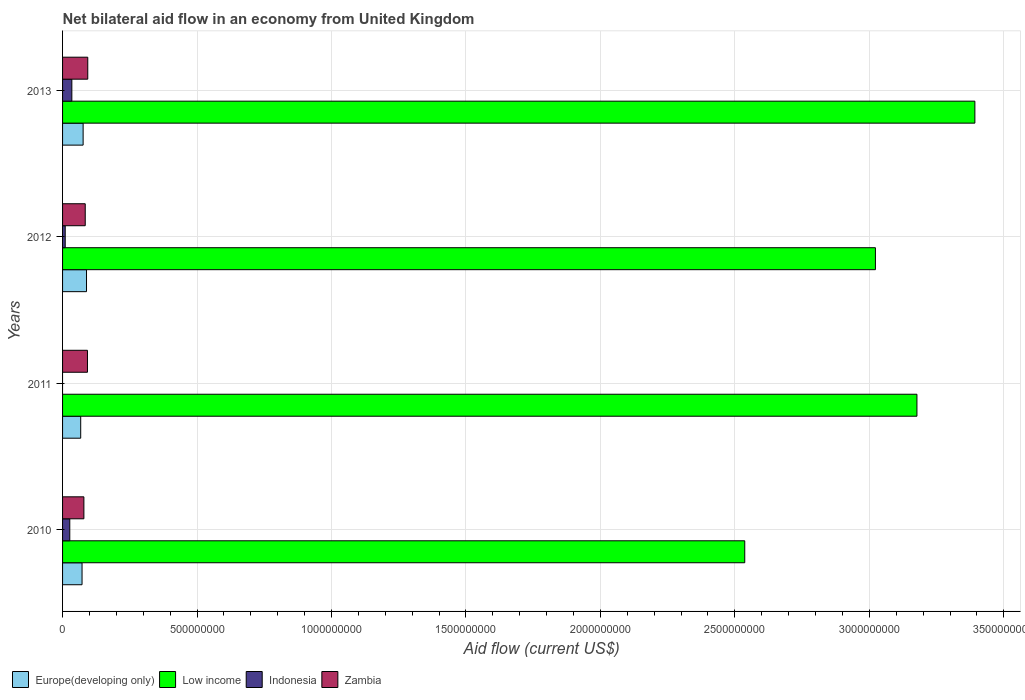How many different coloured bars are there?
Your response must be concise. 4. Are the number of bars on each tick of the Y-axis equal?
Your response must be concise. No. What is the label of the 1st group of bars from the top?
Give a very brief answer. 2013. In how many cases, is the number of bars for a given year not equal to the number of legend labels?
Offer a terse response. 1. What is the net bilateral aid flow in Europe(developing only) in 2011?
Your answer should be very brief. 6.74e+07. Across all years, what is the maximum net bilateral aid flow in Low income?
Offer a terse response. 3.39e+09. Across all years, what is the minimum net bilateral aid flow in Indonesia?
Keep it short and to the point. 0. In which year was the net bilateral aid flow in Europe(developing only) maximum?
Your answer should be compact. 2012. What is the total net bilateral aid flow in Europe(developing only) in the graph?
Give a very brief answer. 3.05e+08. What is the difference between the net bilateral aid flow in Zambia in 2010 and that in 2013?
Provide a succinct answer. -1.44e+07. What is the difference between the net bilateral aid flow in Low income in 2010 and the net bilateral aid flow in Indonesia in 2012?
Your response must be concise. 2.53e+09. What is the average net bilateral aid flow in Europe(developing only) per year?
Offer a very short reply. 7.63e+07. In the year 2013, what is the difference between the net bilateral aid flow in Indonesia and net bilateral aid flow in Europe(developing only)?
Your answer should be very brief. -4.19e+07. What is the ratio of the net bilateral aid flow in Zambia in 2011 to that in 2012?
Your response must be concise. 1.1. Is the difference between the net bilateral aid flow in Indonesia in 2010 and 2012 greater than the difference between the net bilateral aid flow in Europe(developing only) in 2010 and 2012?
Ensure brevity in your answer.  Yes. What is the difference between the highest and the second highest net bilateral aid flow in Low income?
Provide a short and direct response. 2.15e+08. What is the difference between the highest and the lowest net bilateral aid flow in Zambia?
Your answer should be very brief. 1.44e+07. In how many years, is the net bilateral aid flow in Europe(developing only) greater than the average net bilateral aid flow in Europe(developing only) taken over all years?
Provide a short and direct response. 2. Is it the case that in every year, the sum of the net bilateral aid flow in Indonesia and net bilateral aid flow in Zambia is greater than the sum of net bilateral aid flow in Europe(developing only) and net bilateral aid flow in Low income?
Your response must be concise. No. How many bars are there?
Offer a very short reply. 15. Does the graph contain any zero values?
Offer a terse response. Yes. Does the graph contain grids?
Your response must be concise. Yes. What is the title of the graph?
Provide a succinct answer. Net bilateral aid flow in an economy from United Kingdom. What is the label or title of the Y-axis?
Offer a very short reply. Years. What is the Aid flow (current US$) of Europe(developing only) in 2010?
Provide a succinct answer. 7.25e+07. What is the Aid flow (current US$) of Low income in 2010?
Give a very brief answer. 2.54e+09. What is the Aid flow (current US$) in Indonesia in 2010?
Provide a short and direct response. 2.68e+07. What is the Aid flow (current US$) of Zambia in 2010?
Your response must be concise. 7.93e+07. What is the Aid flow (current US$) in Europe(developing only) in 2011?
Provide a short and direct response. 6.74e+07. What is the Aid flow (current US$) in Low income in 2011?
Keep it short and to the point. 3.18e+09. What is the Aid flow (current US$) in Zambia in 2011?
Give a very brief answer. 9.26e+07. What is the Aid flow (current US$) in Europe(developing only) in 2012?
Give a very brief answer. 8.90e+07. What is the Aid flow (current US$) in Low income in 2012?
Your answer should be very brief. 3.02e+09. What is the Aid flow (current US$) of Indonesia in 2012?
Your answer should be very brief. 9.88e+06. What is the Aid flow (current US$) of Zambia in 2012?
Make the answer very short. 8.43e+07. What is the Aid flow (current US$) of Europe(developing only) in 2013?
Ensure brevity in your answer.  7.64e+07. What is the Aid flow (current US$) of Low income in 2013?
Your answer should be very brief. 3.39e+09. What is the Aid flow (current US$) in Indonesia in 2013?
Ensure brevity in your answer.  3.45e+07. What is the Aid flow (current US$) of Zambia in 2013?
Your answer should be very brief. 9.37e+07. Across all years, what is the maximum Aid flow (current US$) in Europe(developing only)?
Give a very brief answer. 8.90e+07. Across all years, what is the maximum Aid flow (current US$) of Low income?
Make the answer very short. 3.39e+09. Across all years, what is the maximum Aid flow (current US$) in Indonesia?
Keep it short and to the point. 3.45e+07. Across all years, what is the maximum Aid flow (current US$) in Zambia?
Provide a succinct answer. 9.37e+07. Across all years, what is the minimum Aid flow (current US$) of Europe(developing only)?
Your answer should be compact. 6.74e+07. Across all years, what is the minimum Aid flow (current US$) of Low income?
Offer a very short reply. 2.54e+09. Across all years, what is the minimum Aid flow (current US$) in Zambia?
Your answer should be very brief. 7.93e+07. What is the total Aid flow (current US$) of Europe(developing only) in the graph?
Ensure brevity in your answer.  3.05e+08. What is the total Aid flow (current US$) of Low income in the graph?
Keep it short and to the point. 1.21e+1. What is the total Aid flow (current US$) in Indonesia in the graph?
Give a very brief answer. 7.12e+07. What is the total Aid flow (current US$) of Zambia in the graph?
Make the answer very short. 3.50e+08. What is the difference between the Aid flow (current US$) of Europe(developing only) in 2010 and that in 2011?
Your response must be concise. 5.03e+06. What is the difference between the Aid flow (current US$) in Low income in 2010 and that in 2011?
Provide a short and direct response. -6.40e+08. What is the difference between the Aid flow (current US$) in Zambia in 2010 and that in 2011?
Give a very brief answer. -1.33e+07. What is the difference between the Aid flow (current US$) of Europe(developing only) in 2010 and that in 2012?
Keep it short and to the point. -1.66e+07. What is the difference between the Aid flow (current US$) in Low income in 2010 and that in 2012?
Provide a short and direct response. -4.86e+08. What is the difference between the Aid flow (current US$) in Indonesia in 2010 and that in 2012?
Your answer should be compact. 1.70e+07. What is the difference between the Aid flow (current US$) in Zambia in 2010 and that in 2012?
Ensure brevity in your answer.  -4.97e+06. What is the difference between the Aid flow (current US$) in Europe(developing only) in 2010 and that in 2013?
Offer a terse response. -3.98e+06. What is the difference between the Aid flow (current US$) of Low income in 2010 and that in 2013?
Your response must be concise. -8.56e+08. What is the difference between the Aid flow (current US$) in Indonesia in 2010 and that in 2013?
Offer a terse response. -7.66e+06. What is the difference between the Aid flow (current US$) of Zambia in 2010 and that in 2013?
Offer a very short reply. -1.44e+07. What is the difference between the Aid flow (current US$) of Europe(developing only) in 2011 and that in 2012?
Offer a terse response. -2.16e+07. What is the difference between the Aid flow (current US$) of Low income in 2011 and that in 2012?
Your answer should be compact. 1.54e+08. What is the difference between the Aid flow (current US$) in Zambia in 2011 and that in 2012?
Your answer should be compact. 8.32e+06. What is the difference between the Aid flow (current US$) in Europe(developing only) in 2011 and that in 2013?
Provide a succinct answer. -9.01e+06. What is the difference between the Aid flow (current US$) in Low income in 2011 and that in 2013?
Your response must be concise. -2.15e+08. What is the difference between the Aid flow (current US$) of Zambia in 2011 and that in 2013?
Ensure brevity in your answer.  -1.13e+06. What is the difference between the Aid flow (current US$) in Europe(developing only) in 2012 and that in 2013?
Provide a succinct answer. 1.26e+07. What is the difference between the Aid flow (current US$) in Low income in 2012 and that in 2013?
Make the answer very short. -3.70e+08. What is the difference between the Aid flow (current US$) of Indonesia in 2012 and that in 2013?
Give a very brief answer. -2.46e+07. What is the difference between the Aid flow (current US$) in Zambia in 2012 and that in 2013?
Ensure brevity in your answer.  -9.45e+06. What is the difference between the Aid flow (current US$) of Europe(developing only) in 2010 and the Aid flow (current US$) of Low income in 2011?
Offer a terse response. -3.10e+09. What is the difference between the Aid flow (current US$) in Europe(developing only) in 2010 and the Aid flow (current US$) in Zambia in 2011?
Keep it short and to the point. -2.01e+07. What is the difference between the Aid flow (current US$) in Low income in 2010 and the Aid flow (current US$) in Zambia in 2011?
Offer a very short reply. 2.44e+09. What is the difference between the Aid flow (current US$) of Indonesia in 2010 and the Aid flow (current US$) of Zambia in 2011?
Your answer should be very brief. -6.57e+07. What is the difference between the Aid flow (current US$) of Europe(developing only) in 2010 and the Aid flow (current US$) of Low income in 2012?
Give a very brief answer. -2.95e+09. What is the difference between the Aid flow (current US$) in Europe(developing only) in 2010 and the Aid flow (current US$) in Indonesia in 2012?
Your response must be concise. 6.26e+07. What is the difference between the Aid flow (current US$) in Europe(developing only) in 2010 and the Aid flow (current US$) in Zambia in 2012?
Ensure brevity in your answer.  -1.18e+07. What is the difference between the Aid flow (current US$) of Low income in 2010 and the Aid flow (current US$) of Indonesia in 2012?
Make the answer very short. 2.53e+09. What is the difference between the Aid flow (current US$) of Low income in 2010 and the Aid flow (current US$) of Zambia in 2012?
Offer a very short reply. 2.45e+09. What is the difference between the Aid flow (current US$) in Indonesia in 2010 and the Aid flow (current US$) in Zambia in 2012?
Keep it short and to the point. -5.74e+07. What is the difference between the Aid flow (current US$) of Europe(developing only) in 2010 and the Aid flow (current US$) of Low income in 2013?
Your answer should be compact. -3.32e+09. What is the difference between the Aid flow (current US$) of Europe(developing only) in 2010 and the Aid flow (current US$) of Indonesia in 2013?
Offer a very short reply. 3.80e+07. What is the difference between the Aid flow (current US$) in Europe(developing only) in 2010 and the Aid flow (current US$) in Zambia in 2013?
Provide a short and direct response. -2.13e+07. What is the difference between the Aid flow (current US$) of Low income in 2010 and the Aid flow (current US$) of Indonesia in 2013?
Offer a very short reply. 2.50e+09. What is the difference between the Aid flow (current US$) of Low income in 2010 and the Aid flow (current US$) of Zambia in 2013?
Your answer should be compact. 2.44e+09. What is the difference between the Aid flow (current US$) in Indonesia in 2010 and the Aid flow (current US$) in Zambia in 2013?
Offer a very short reply. -6.69e+07. What is the difference between the Aid flow (current US$) in Europe(developing only) in 2011 and the Aid flow (current US$) in Low income in 2012?
Keep it short and to the point. -2.96e+09. What is the difference between the Aid flow (current US$) of Europe(developing only) in 2011 and the Aid flow (current US$) of Indonesia in 2012?
Provide a succinct answer. 5.76e+07. What is the difference between the Aid flow (current US$) in Europe(developing only) in 2011 and the Aid flow (current US$) in Zambia in 2012?
Provide a succinct answer. -1.68e+07. What is the difference between the Aid flow (current US$) of Low income in 2011 and the Aid flow (current US$) of Indonesia in 2012?
Make the answer very short. 3.17e+09. What is the difference between the Aid flow (current US$) in Low income in 2011 and the Aid flow (current US$) in Zambia in 2012?
Offer a very short reply. 3.09e+09. What is the difference between the Aid flow (current US$) of Europe(developing only) in 2011 and the Aid flow (current US$) of Low income in 2013?
Your answer should be very brief. -3.33e+09. What is the difference between the Aid flow (current US$) of Europe(developing only) in 2011 and the Aid flow (current US$) of Indonesia in 2013?
Make the answer very short. 3.29e+07. What is the difference between the Aid flow (current US$) of Europe(developing only) in 2011 and the Aid flow (current US$) of Zambia in 2013?
Your answer should be compact. -2.63e+07. What is the difference between the Aid flow (current US$) of Low income in 2011 and the Aid flow (current US$) of Indonesia in 2013?
Your answer should be compact. 3.14e+09. What is the difference between the Aid flow (current US$) in Low income in 2011 and the Aid flow (current US$) in Zambia in 2013?
Offer a terse response. 3.08e+09. What is the difference between the Aid flow (current US$) of Europe(developing only) in 2012 and the Aid flow (current US$) of Low income in 2013?
Provide a short and direct response. -3.30e+09. What is the difference between the Aid flow (current US$) of Europe(developing only) in 2012 and the Aid flow (current US$) of Indonesia in 2013?
Keep it short and to the point. 5.45e+07. What is the difference between the Aid flow (current US$) of Europe(developing only) in 2012 and the Aid flow (current US$) of Zambia in 2013?
Your answer should be compact. -4.67e+06. What is the difference between the Aid flow (current US$) in Low income in 2012 and the Aid flow (current US$) in Indonesia in 2013?
Offer a very short reply. 2.99e+09. What is the difference between the Aid flow (current US$) in Low income in 2012 and the Aid flow (current US$) in Zambia in 2013?
Your answer should be compact. 2.93e+09. What is the difference between the Aid flow (current US$) in Indonesia in 2012 and the Aid flow (current US$) in Zambia in 2013?
Your answer should be compact. -8.38e+07. What is the average Aid flow (current US$) of Europe(developing only) per year?
Ensure brevity in your answer.  7.63e+07. What is the average Aid flow (current US$) in Low income per year?
Make the answer very short. 3.03e+09. What is the average Aid flow (current US$) in Indonesia per year?
Give a very brief answer. 1.78e+07. What is the average Aid flow (current US$) in Zambia per year?
Provide a succinct answer. 8.75e+07. In the year 2010, what is the difference between the Aid flow (current US$) of Europe(developing only) and Aid flow (current US$) of Low income?
Give a very brief answer. -2.46e+09. In the year 2010, what is the difference between the Aid flow (current US$) of Europe(developing only) and Aid flow (current US$) of Indonesia?
Provide a short and direct response. 4.56e+07. In the year 2010, what is the difference between the Aid flow (current US$) in Europe(developing only) and Aid flow (current US$) in Zambia?
Provide a short and direct response. -6.84e+06. In the year 2010, what is the difference between the Aid flow (current US$) in Low income and Aid flow (current US$) in Indonesia?
Ensure brevity in your answer.  2.51e+09. In the year 2010, what is the difference between the Aid flow (current US$) of Low income and Aid flow (current US$) of Zambia?
Provide a succinct answer. 2.46e+09. In the year 2010, what is the difference between the Aid flow (current US$) in Indonesia and Aid flow (current US$) in Zambia?
Your response must be concise. -5.24e+07. In the year 2011, what is the difference between the Aid flow (current US$) in Europe(developing only) and Aid flow (current US$) in Low income?
Keep it short and to the point. -3.11e+09. In the year 2011, what is the difference between the Aid flow (current US$) in Europe(developing only) and Aid flow (current US$) in Zambia?
Give a very brief answer. -2.52e+07. In the year 2011, what is the difference between the Aid flow (current US$) of Low income and Aid flow (current US$) of Zambia?
Provide a short and direct response. 3.08e+09. In the year 2012, what is the difference between the Aid flow (current US$) of Europe(developing only) and Aid flow (current US$) of Low income?
Offer a terse response. -2.93e+09. In the year 2012, what is the difference between the Aid flow (current US$) in Europe(developing only) and Aid flow (current US$) in Indonesia?
Make the answer very short. 7.92e+07. In the year 2012, what is the difference between the Aid flow (current US$) of Europe(developing only) and Aid flow (current US$) of Zambia?
Offer a very short reply. 4.78e+06. In the year 2012, what is the difference between the Aid flow (current US$) in Low income and Aid flow (current US$) in Indonesia?
Your response must be concise. 3.01e+09. In the year 2012, what is the difference between the Aid flow (current US$) in Low income and Aid flow (current US$) in Zambia?
Ensure brevity in your answer.  2.94e+09. In the year 2012, what is the difference between the Aid flow (current US$) of Indonesia and Aid flow (current US$) of Zambia?
Give a very brief answer. -7.44e+07. In the year 2013, what is the difference between the Aid flow (current US$) in Europe(developing only) and Aid flow (current US$) in Low income?
Keep it short and to the point. -3.32e+09. In the year 2013, what is the difference between the Aid flow (current US$) of Europe(developing only) and Aid flow (current US$) of Indonesia?
Your response must be concise. 4.19e+07. In the year 2013, what is the difference between the Aid flow (current US$) in Europe(developing only) and Aid flow (current US$) in Zambia?
Provide a short and direct response. -1.73e+07. In the year 2013, what is the difference between the Aid flow (current US$) in Low income and Aid flow (current US$) in Indonesia?
Your answer should be very brief. 3.36e+09. In the year 2013, what is the difference between the Aid flow (current US$) in Low income and Aid flow (current US$) in Zambia?
Provide a short and direct response. 3.30e+09. In the year 2013, what is the difference between the Aid flow (current US$) of Indonesia and Aid flow (current US$) of Zambia?
Your response must be concise. -5.92e+07. What is the ratio of the Aid flow (current US$) in Europe(developing only) in 2010 to that in 2011?
Keep it short and to the point. 1.07. What is the ratio of the Aid flow (current US$) in Low income in 2010 to that in 2011?
Your answer should be compact. 0.8. What is the ratio of the Aid flow (current US$) in Zambia in 2010 to that in 2011?
Provide a short and direct response. 0.86. What is the ratio of the Aid flow (current US$) in Europe(developing only) in 2010 to that in 2012?
Give a very brief answer. 0.81. What is the ratio of the Aid flow (current US$) in Low income in 2010 to that in 2012?
Keep it short and to the point. 0.84. What is the ratio of the Aid flow (current US$) of Indonesia in 2010 to that in 2012?
Provide a short and direct response. 2.72. What is the ratio of the Aid flow (current US$) in Zambia in 2010 to that in 2012?
Ensure brevity in your answer.  0.94. What is the ratio of the Aid flow (current US$) in Europe(developing only) in 2010 to that in 2013?
Make the answer very short. 0.95. What is the ratio of the Aid flow (current US$) of Low income in 2010 to that in 2013?
Make the answer very short. 0.75. What is the ratio of the Aid flow (current US$) in Indonesia in 2010 to that in 2013?
Make the answer very short. 0.78. What is the ratio of the Aid flow (current US$) of Zambia in 2010 to that in 2013?
Give a very brief answer. 0.85. What is the ratio of the Aid flow (current US$) in Europe(developing only) in 2011 to that in 2012?
Make the answer very short. 0.76. What is the ratio of the Aid flow (current US$) of Low income in 2011 to that in 2012?
Ensure brevity in your answer.  1.05. What is the ratio of the Aid flow (current US$) of Zambia in 2011 to that in 2012?
Ensure brevity in your answer.  1.1. What is the ratio of the Aid flow (current US$) of Europe(developing only) in 2011 to that in 2013?
Your answer should be very brief. 0.88. What is the ratio of the Aid flow (current US$) of Low income in 2011 to that in 2013?
Keep it short and to the point. 0.94. What is the ratio of the Aid flow (current US$) of Zambia in 2011 to that in 2013?
Your response must be concise. 0.99. What is the ratio of the Aid flow (current US$) of Europe(developing only) in 2012 to that in 2013?
Your answer should be compact. 1.17. What is the ratio of the Aid flow (current US$) in Low income in 2012 to that in 2013?
Make the answer very short. 0.89. What is the ratio of the Aid flow (current US$) in Indonesia in 2012 to that in 2013?
Offer a very short reply. 0.29. What is the ratio of the Aid flow (current US$) in Zambia in 2012 to that in 2013?
Your response must be concise. 0.9. What is the difference between the highest and the second highest Aid flow (current US$) in Europe(developing only)?
Your response must be concise. 1.26e+07. What is the difference between the highest and the second highest Aid flow (current US$) of Low income?
Offer a very short reply. 2.15e+08. What is the difference between the highest and the second highest Aid flow (current US$) of Indonesia?
Keep it short and to the point. 7.66e+06. What is the difference between the highest and the second highest Aid flow (current US$) in Zambia?
Give a very brief answer. 1.13e+06. What is the difference between the highest and the lowest Aid flow (current US$) in Europe(developing only)?
Provide a succinct answer. 2.16e+07. What is the difference between the highest and the lowest Aid flow (current US$) in Low income?
Your answer should be compact. 8.56e+08. What is the difference between the highest and the lowest Aid flow (current US$) of Indonesia?
Your answer should be very brief. 3.45e+07. What is the difference between the highest and the lowest Aid flow (current US$) of Zambia?
Offer a terse response. 1.44e+07. 